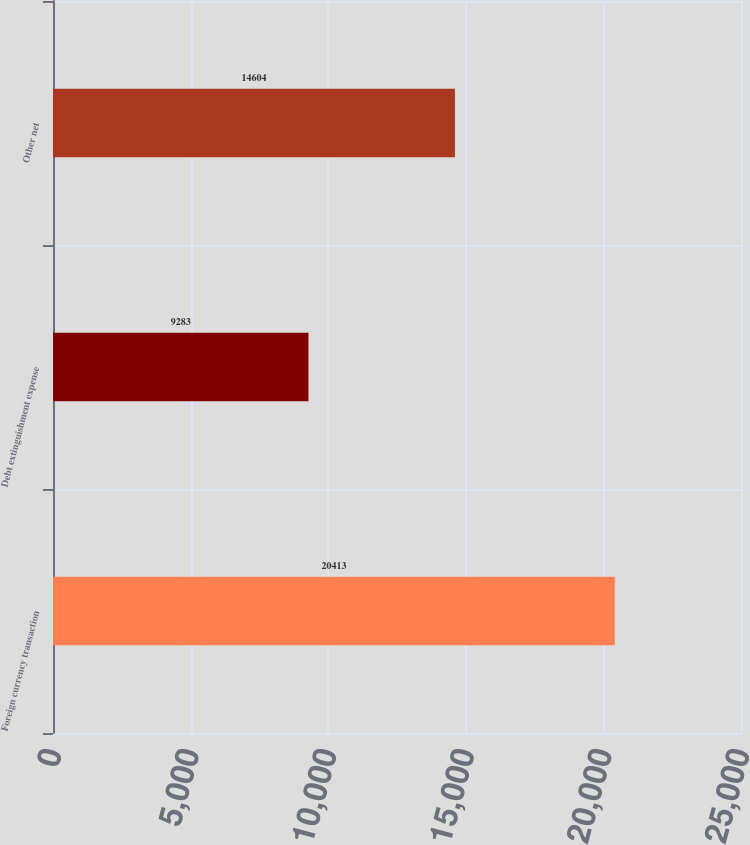Convert chart to OTSL. <chart><loc_0><loc_0><loc_500><loc_500><bar_chart><fcel>Foreign currency transaction<fcel>Debt extinguishment expense<fcel>Other net<nl><fcel>20413<fcel>9283<fcel>14604<nl></chart> 